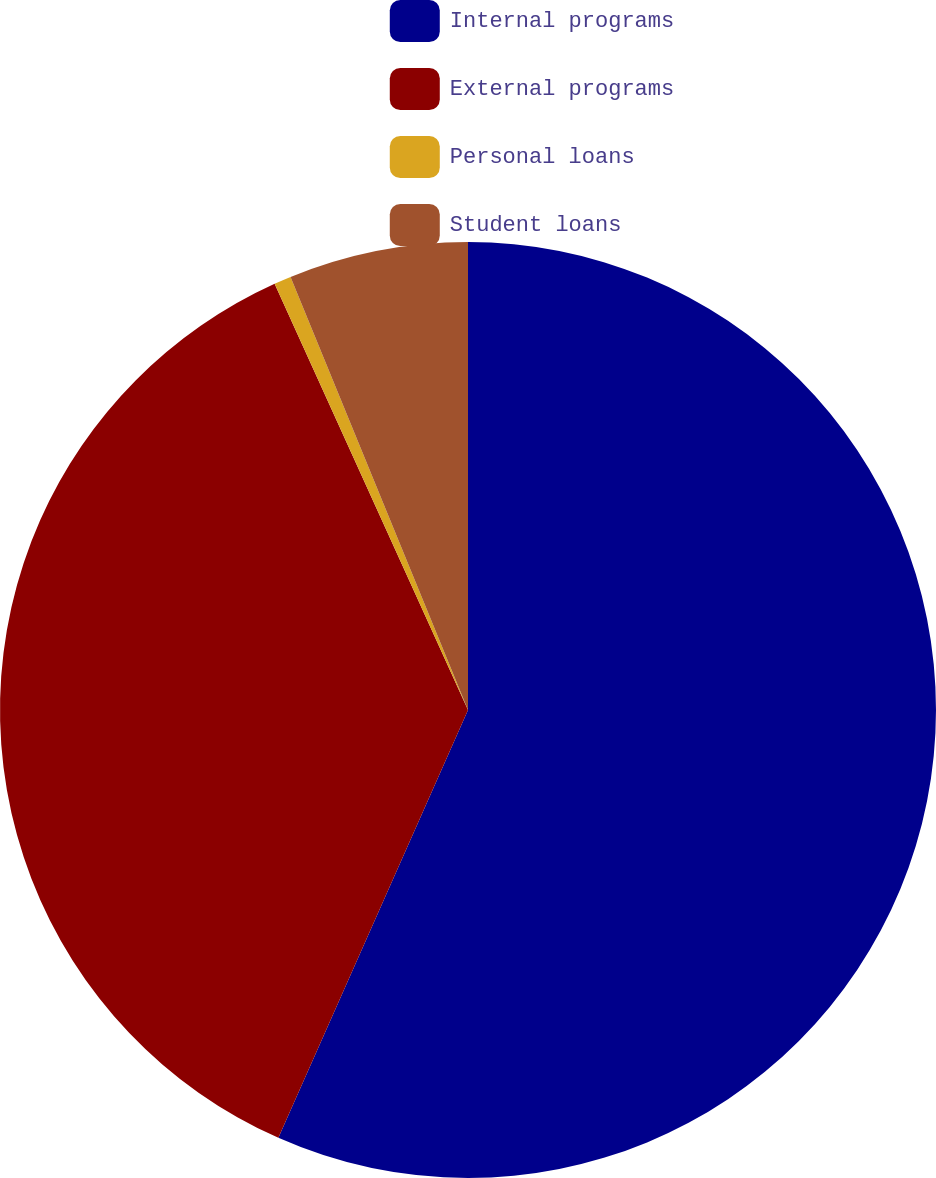Convert chart to OTSL. <chart><loc_0><loc_0><loc_500><loc_500><pie_chart><fcel>Internal programs<fcel>External programs<fcel>Personal loans<fcel>Student loans<nl><fcel>56.64%<fcel>36.58%<fcel>0.59%<fcel>6.19%<nl></chart> 